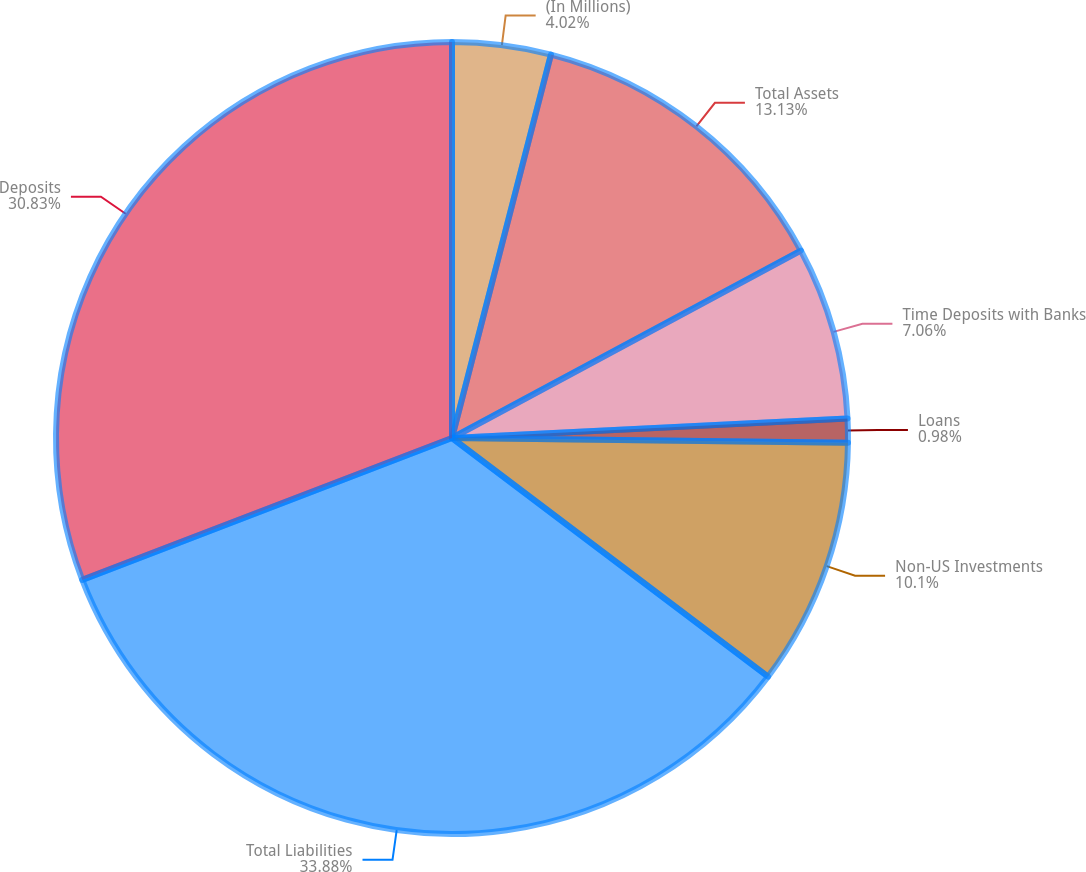Convert chart. <chart><loc_0><loc_0><loc_500><loc_500><pie_chart><fcel>(In Millions)<fcel>Total Assets<fcel>Time Deposits with Banks<fcel>Loans<fcel>Non-US Investments<fcel>Total Liabilities<fcel>Deposits<nl><fcel>4.02%<fcel>13.13%<fcel>7.06%<fcel>0.98%<fcel>10.1%<fcel>33.87%<fcel>30.83%<nl></chart> 